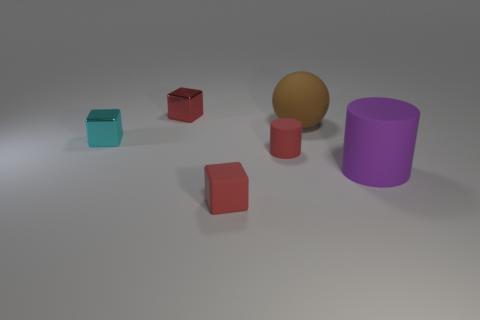There is a metallic object that is the same color as the small cylinder; what is its size?
Offer a very short reply. Small. Does the small rubber cylinder have the same color as the rubber cube?
Offer a very short reply. Yes. What color is the large rubber cylinder?
Your response must be concise. Purple. What number of other objects are the same material as the large ball?
Make the answer very short. 3. What number of brown things are either large rubber balls or small objects?
Keep it short and to the point. 1. There is a large object in front of the brown rubber object; is its shape the same as the small red matte thing that is behind the large purple cylinder?
Offer a very short reply. Yes. There is a small cylinder; is it the same color as the tiny shiny block right of the cyan cube?
Make the answer very short. Yes. Do the block that is behind the tiny cyan metal object and the matte block have the same color?
Offer a very short reply. Yes. What number of objects are green matte cubes or small blocks that are on the right side of the small cyan thing?
Make the answer very short. 2. There is a small object that is on the left side of the red cylinder and in front of the cyan thing; what is its material?
Keep it short and to the point. Rubber. 